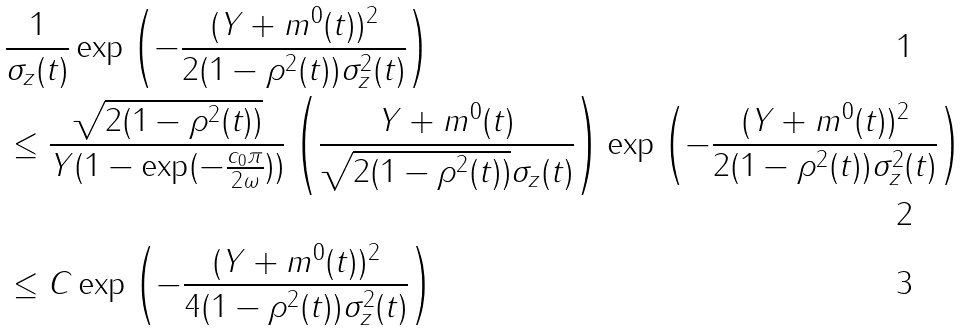<formula> <loc_0><loc_0><loc_500><loc_500>& \frac { 1 } { \sigma _ { z } ( t ) } \exp \left ( - \frac { ( Y + m ^ { 0 } ( t ) ) ^ { 2 } } { 2 ( 1 - \rho ^ { 2 } ( t ) ) \sigma _ { z } ^ { 2 } ( t ) } \right ) \\ & \leq \frac { \sqrt { 2 ( 1 - \rho ^ { 2 } ( t ) ) } } { Y ( 1 - \exp ( - \frac { c _ { 0 } \pi } { 2 \omega } ) ) } \left ( \frac { Y + m ^ { 0 } ( t ) } { \sqrt { 2 ( 1 - \rho ^ { 2 } ( t ) ) } \sigma _ { z } ( t ) } \right ) \exp \left ( - \frac { ( Y + m ^ { 0 } ( t ) ) ^ { 2 } } { 2 ( 1 - \rho ^ { 2 } ( t ) ) \sigma _ { z } ^ { 2 } ( t ) } \right ) \\ & \leq C \exp \left ( - \frac { ( Y + m ^ { 0 } ( t ) ) ^ { 2 } } { 4 ( 1 - \rho ^ { 2 } ( t ) ) \sigma _ { z } ^ { 2 } ( t ) } \right )</formula> 